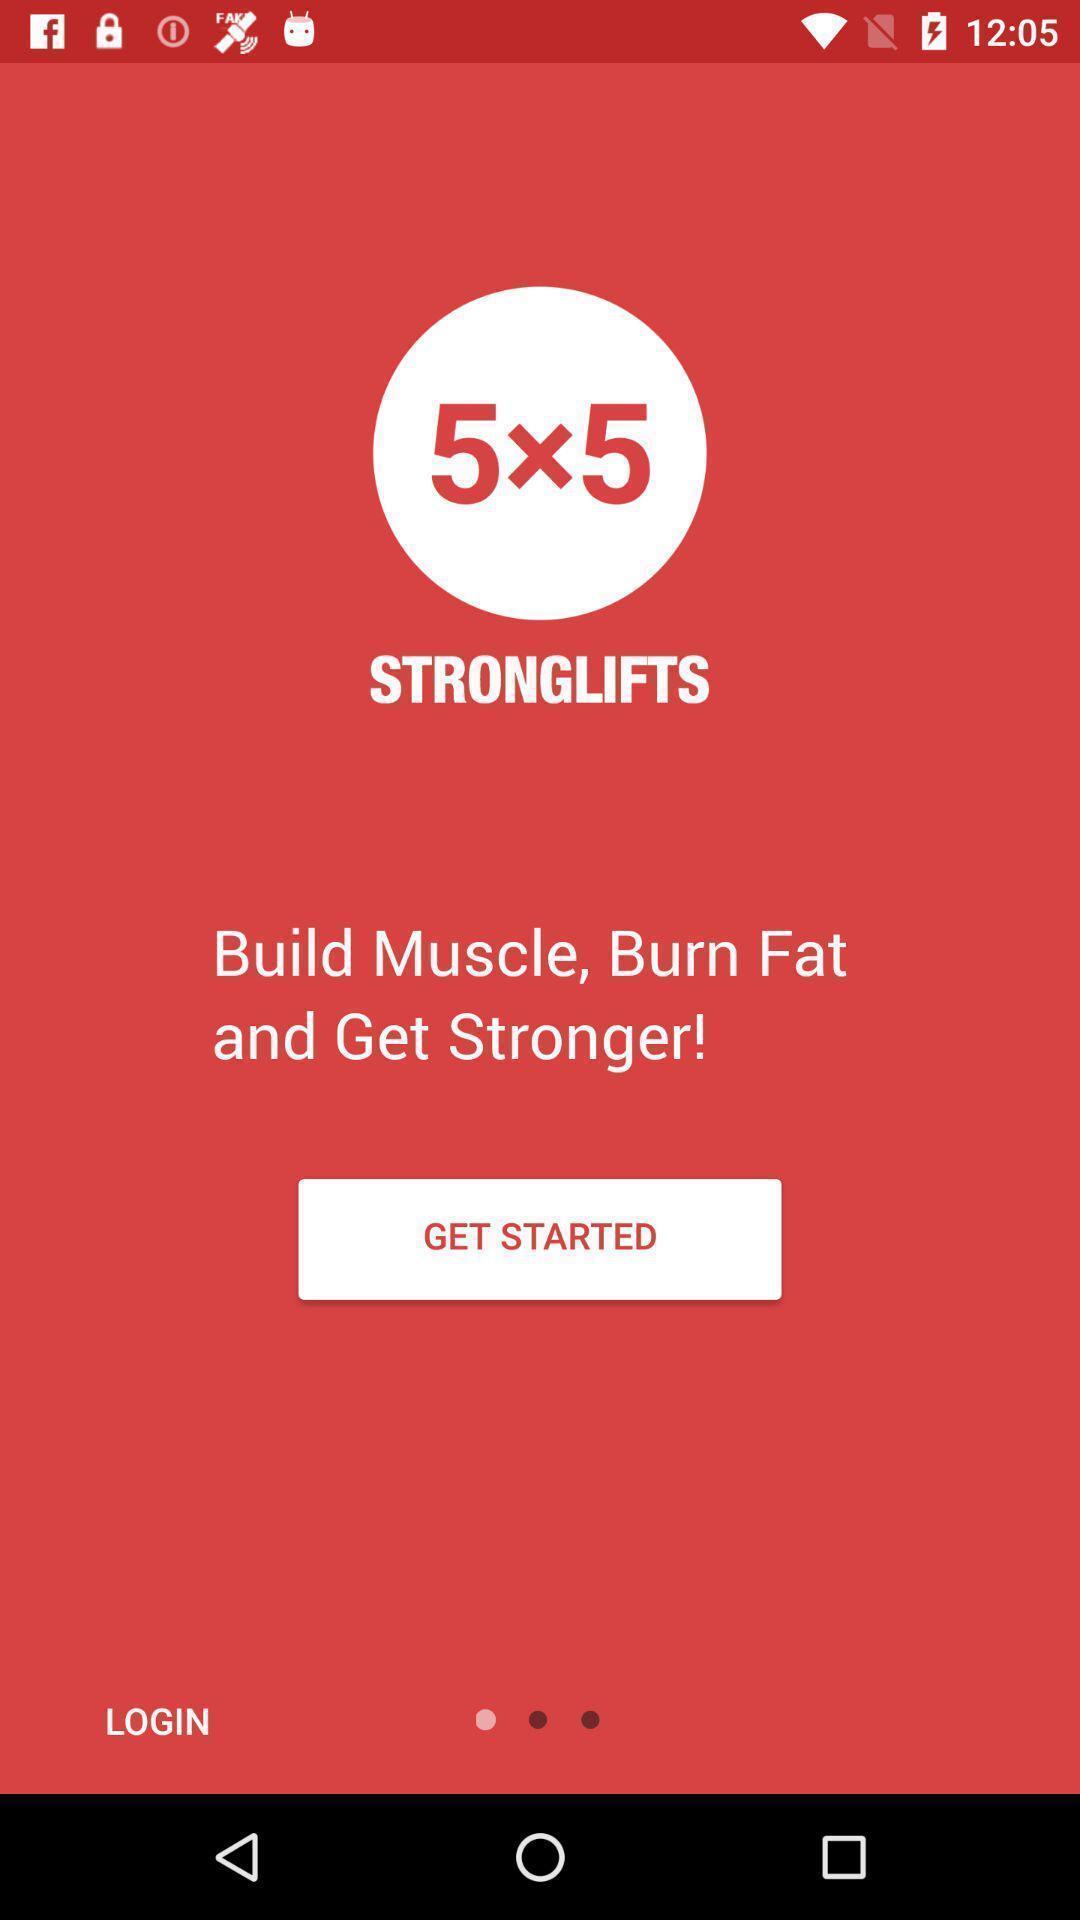Give me a summary of this screen capture. Welcome page of an workout app. 